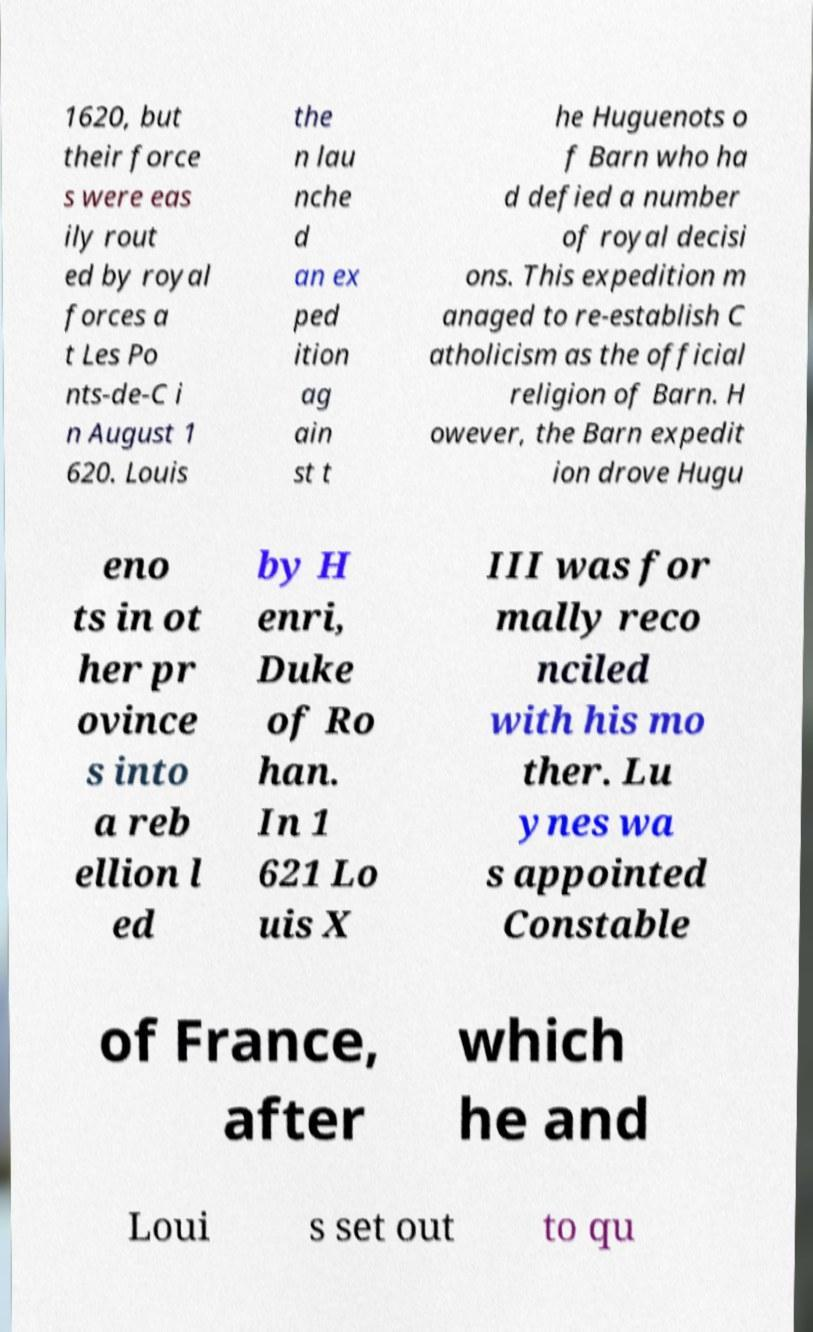Can you read and provide the text displayed in the image?This photo seems to have some interesting text. Can you extract and type it out for me? 1620, but their force s were eas ily rout ed by royal forces a t Les Po nts-de-C i n August 1 620. Louis the n lau nche d an ex ped ition ag ain st t he Huguenots o f Barn who ha d defied a number of royal decisi ons. This expedition m anaged to re-establish C atholicism as the official religion of Barn. H owever, the Barn expedit ion drove Hugu eno ts in ot her pr ovince s into a reb ellion l ed by H enri, Duke of Ro han. In 1 621 Lo uis X III was for mally reco nciled with his mo ther. Lu ynes wa s appointed Constable of France, after which he and Loui s set out to qu 